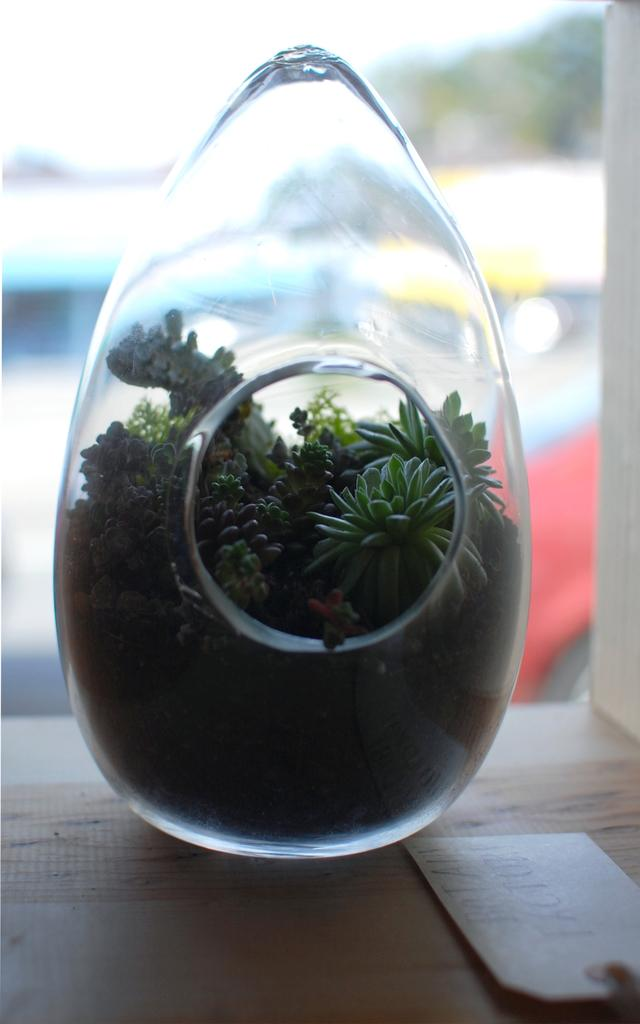What type of object is made of glass in the image? There is a glass object in the image. Can you describe the location of the glass object in the image? The glass object is on a surface. What type of debt is associated with the glass object in the image? There is no mention of debt in the image, and the glass object is not associated with any debt. What type of feather can be seen attached to the glass object in the image? There is no feather present or attached to the glass object in the image. 